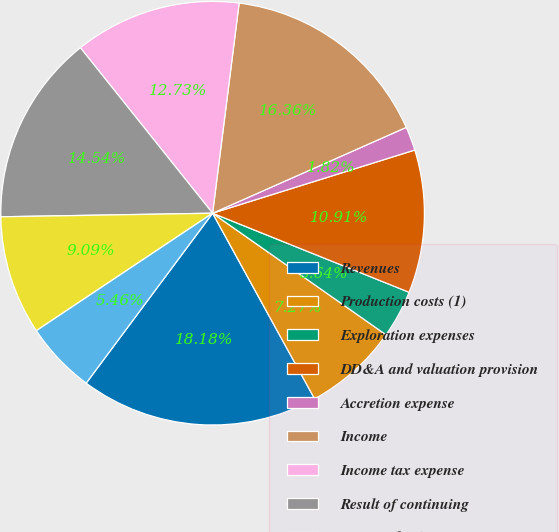<chart> <loc_0><loc_0><loc_500><loc_500><pie_chart><fcel>Revenues<fcel>Production costs (1)<fcel>Exploration expenses<fcel>DD&A and valuation provision<fcel>Accretion expense<fcel>Income<fcel>Income tax expense<fcel>Result of continuing<fcel>Income (loss)<fcel>Income tax expense (benefit)<nl><fcel>18.18%<fcel>7.27%<fcel>3.64%<fcel>10.91%<fcel>1.82%<fcel>16.36%<fcel>12.73%<fcel>14.54%<fcel>9.09%<fcel>5.46%<nl></chart> 